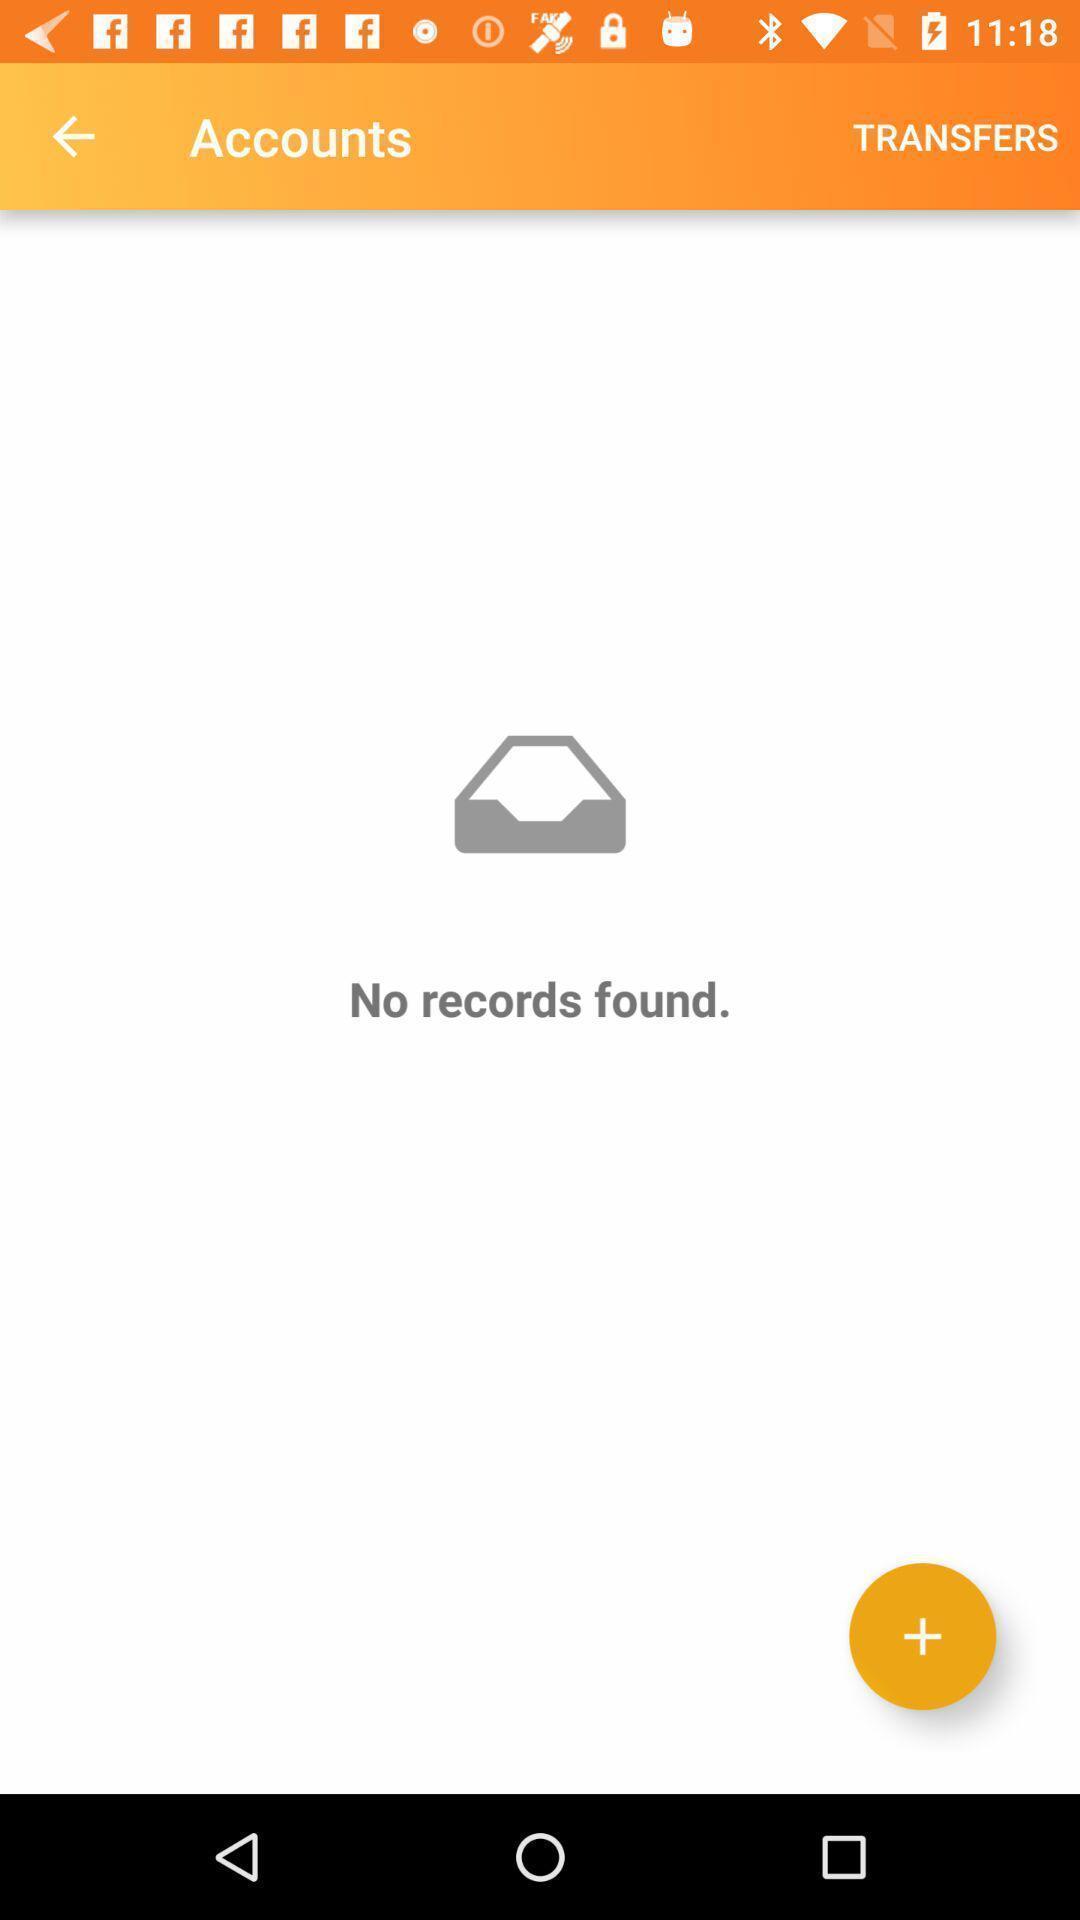Provide a description of this screenshot. Screen displaying contents in accounts page of a financial application. 